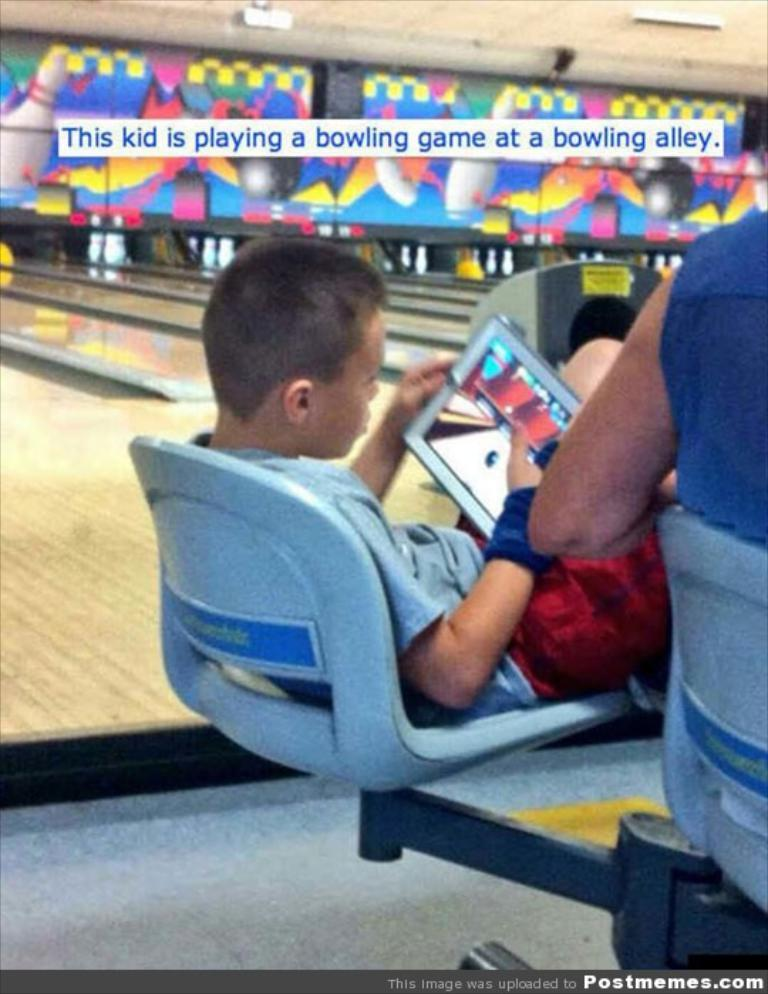<image>
Summarize the visual content of the image. a boy is at the bowling alley playing video games on a tablet 